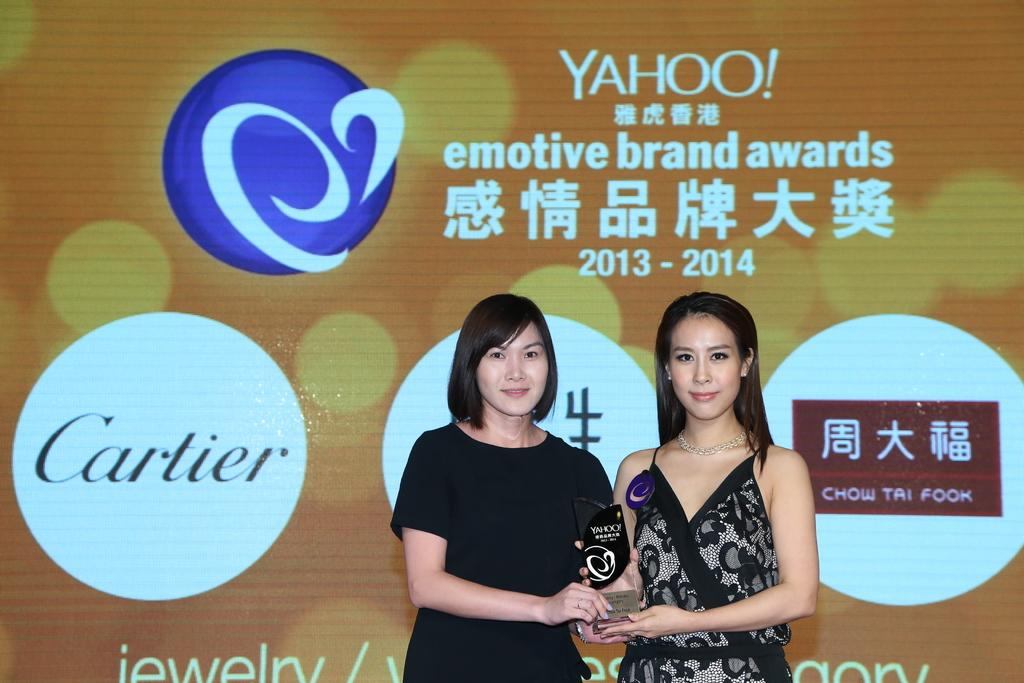How many people are in the image? There are two women in the image. What are the women holding in the image? The women are holding a cup prize. What can be seen in the background of the image? There is a banner visible in the background. What color is the logo in the image? The logo in the image is in blue color. How many cats are sitting on the jelly in the image? There are no cats or jelly present in the image. 